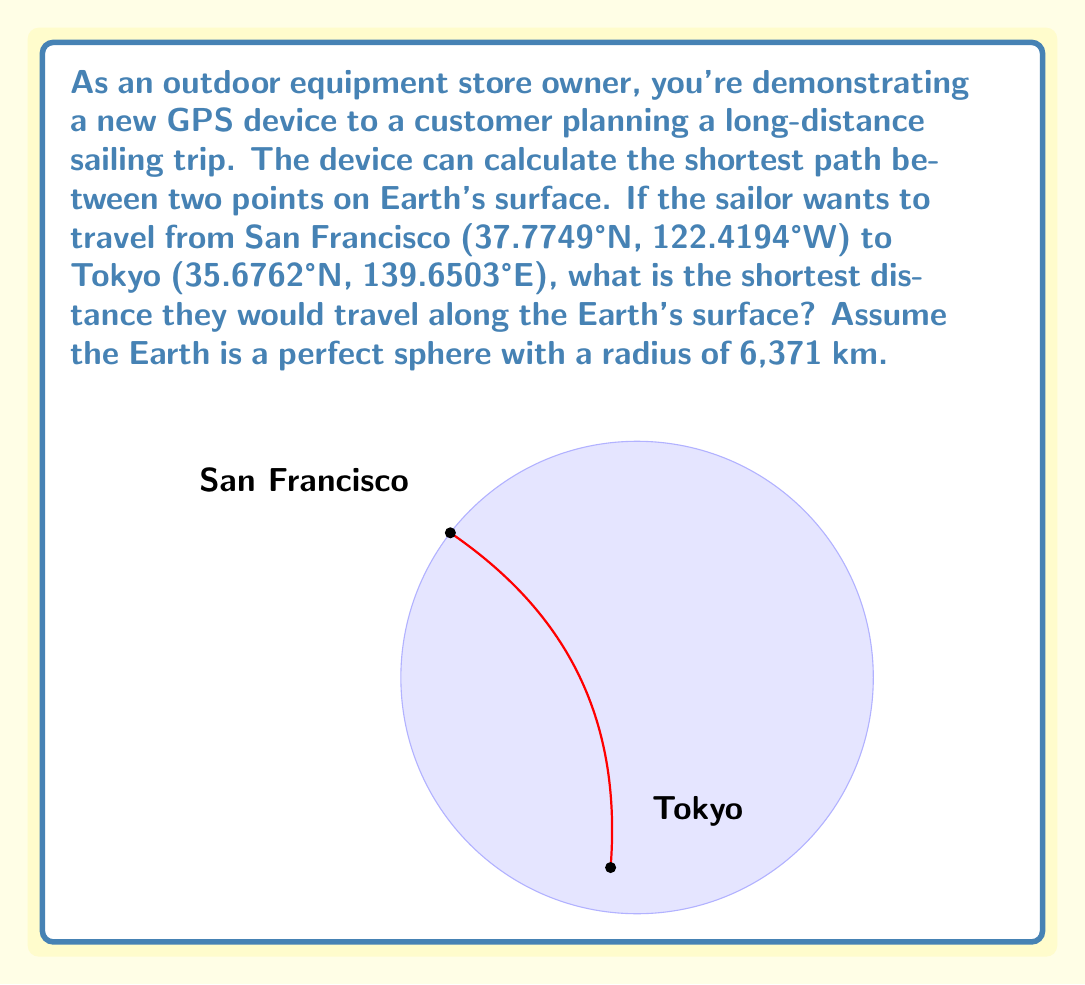What is the answer to this math problem? To solve this problem, we need to use the great circle distance formula, which gives the shortest path between two points on a sphere. The steps are as follows:

1) Convert the latitudes and longitudes to radians:
   $\phi_1 = 37.7749° \times \frac{\pi}{180} = 0.6593$ rad
   $\lambda_1 = -122.4194° \times \frac{\pi}{180} = -2.1366$ rad
   $\phi_2 = 35.6762° \times \frac{\pi}{180} = 0.6226$ rad
   $\lambda_2 = 139.6503° \times \frac{\pi}{180} = 2.4374$ rad

2) Calculate the central angle $\Delta\sigma$ using the haversine formula:
   $$\Delta\sigma = 2 \arcsin\left(\sqrt{\sin^2\left(\frac{\phi_2-\phi_1}{2}\right) + \cos\phi_1\cos\phi_2\sin^2\left(\frac{\lambda_2-\lambda_1}{2}\right)}\right)$$

3) Substitute the values:
   $$\Delta\sigma = 2 \arcsin\left(\sqrt{\sin^2\left(\frac{0.6226-0.6593}{2}\right) + \cos(0.6593)\cos(0.6226)\sin^2\left(\frac{2.4374-(-2.1366)}{2}\right)}\right)$$

4) Calculate:
   $\Delta\sigma \approx 1.4835$ radians

5) The distance $d$ is then given by:
   $d = R \times \Delta\sigma$
   where $R$ is the radius of the Earth (6,371 km)

6) Therefore:
   $d = 6,371 \times 1.4835 \approx 9,450$ km
Answer: 9,450 km 